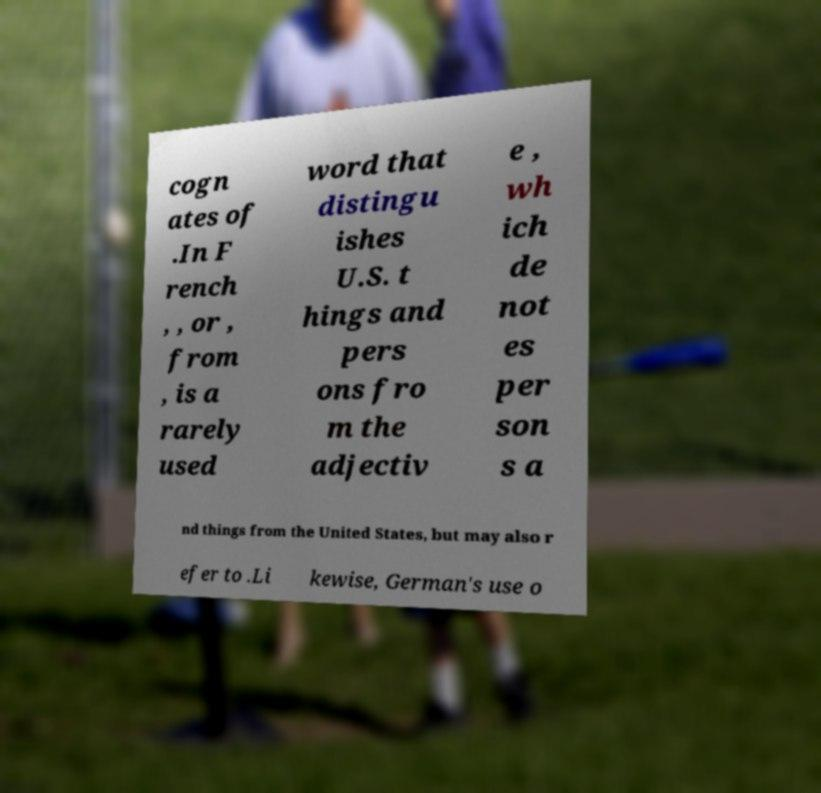Please read and relay the text visible in this image. What does it say? cogn ates of .In F rench , , or , from , is a rarely used word that distingu ishes U.S. t hings and pers ons fro m the adjectiv e , wh ich de not es per son s a nd things from the United States, but may also r efer to .Li kewise, German's use o 